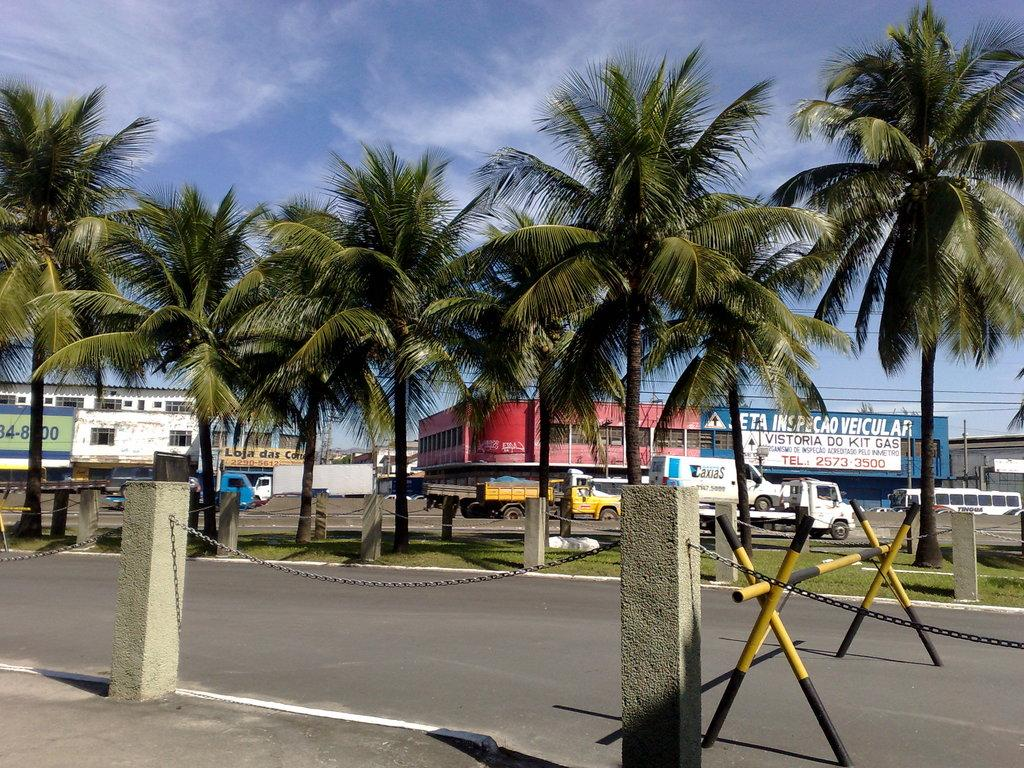What is blocking the road in the image? There is a hurdle on the road in the image. What type of barriers can be seen in the image? There are fences in the image. What type of vegetation is present in the image? Grass is present in the image. What type of natural features can be seen in the image? Trees are visible in the image. What type of man-made structures can be seen in the image? Buildings are visible in the image. What type of signs are present in the image? Name boards are present in the image. What type of transportation is visible in the image? Vehicles are in the image. What else can be seen in the image? There are other objects in the image. What is visible in the background of the image? The sky is visible in the background of the image. Where is the kitten playing in the image? There is no kitten present in the image. What type of downtown area can be seen in the image? The image does not depict a downtown area; it shows a road, fences, trees, buildings, and other objects. 